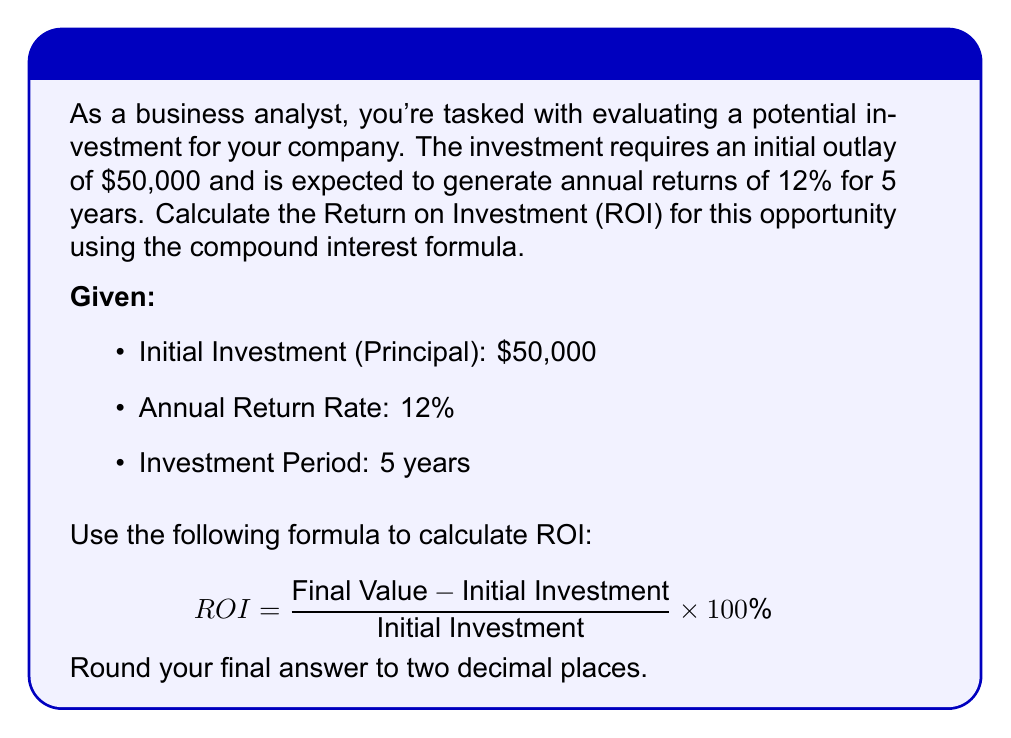What is the answer to this math problem? To solve this problem, we'll follow these steps:

1. Calculate the final value of the investment using the compound interest formula:
   $$ A = P(1 + r)^n $$
   Where:
   A = Final amount
   P = Principal (initial investment)
   r = Annual interest rate (as a decimal)
   n = Number of years

2. Plug in the given values:
   $$ A = 50,000(1 + 0.12)^5 $$

3. Calculate the final amount:
   $$ A = 50,000(1.12)^5 = 50,000(1.7623) = 88,115.62 $$

4. Use the ROI formula:
   $$ ROI = \frac{\text{Final Value} - \text{Initial Investment}}{\text{Initial Investment}} \times 100\% $$

5. Plug in the values:
   $$ ROI = \frac{88,115.62 - 50,000}{50,000} \times 100\% $$

6. Calculate the ROI:
   $$ ROI = \frac{38,115.62}{50,000} \times 100\% = 0.76231 \times 100\% = 76.23\% $$

Therefore, the Return on Investment (ROI) for this opportunity is 76.23%.
Answer: 76.23% 